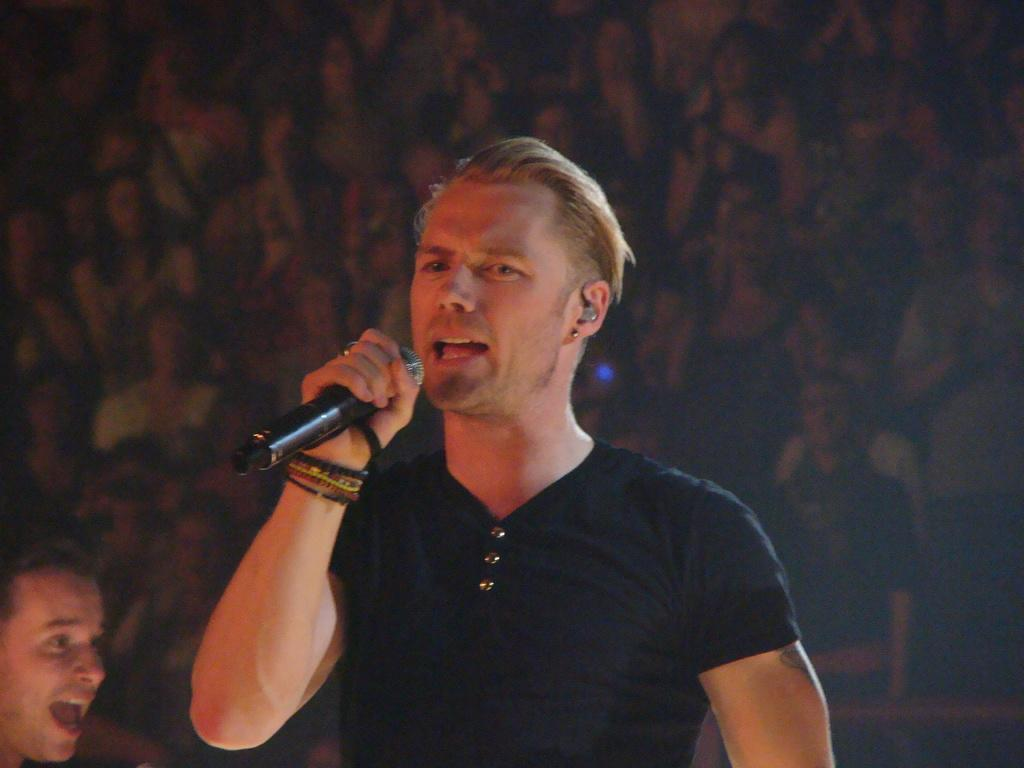What is the man in the image doing? The man is standing and singing in the image. What object is the man holding? The man is holding a microphone. Can you describe the presence of another person in the image? There is another person in the background of the image. What type of pickle is the man using as a prop while singing in the image? There is no pickle present in the image; the man is holding a microphone while singing. 